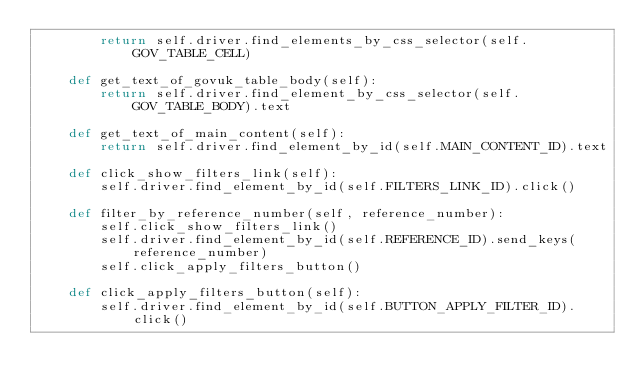Convert code to text. <code><loc_0><loc_0><loc_500><loc_500><_Python_>        return self.driver.find_elements_by_css_selector(self.GOV_TABLE_CELL)

    def get_text_of_govuk_table_body(self):
        return self.driver.find_element_by_css_selector(self.GOV_TABLE_BODY).text

    def get_text_of_main_content(self):
        return self.driver.find_element_by_id(self.MAIN_CONTENT_ID).text

    def click_show_filters_link(self):
        self.driver.find_element_by_id(self.FILTERS_LINK_ID).click()

    def filter_by_reference_number(self, reference_number):
        self.click_show_filters_link()
        self.driver.find_element_by_id(self.REFERENCE_ID).send_keys(reference_number)
        self.click_apply_filters_button()

    def click_apply_filters_button(self):
        self.driver.find_element_by_id(self.BUTTON_APPLY_FILTER_ID).click()
</code> 